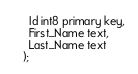<code> <loc_0><loc_0><loc_500><loc_500><_SQL_>  Id int8 primary key,
  First_Name text,
  Last_Name text
);

</code> 